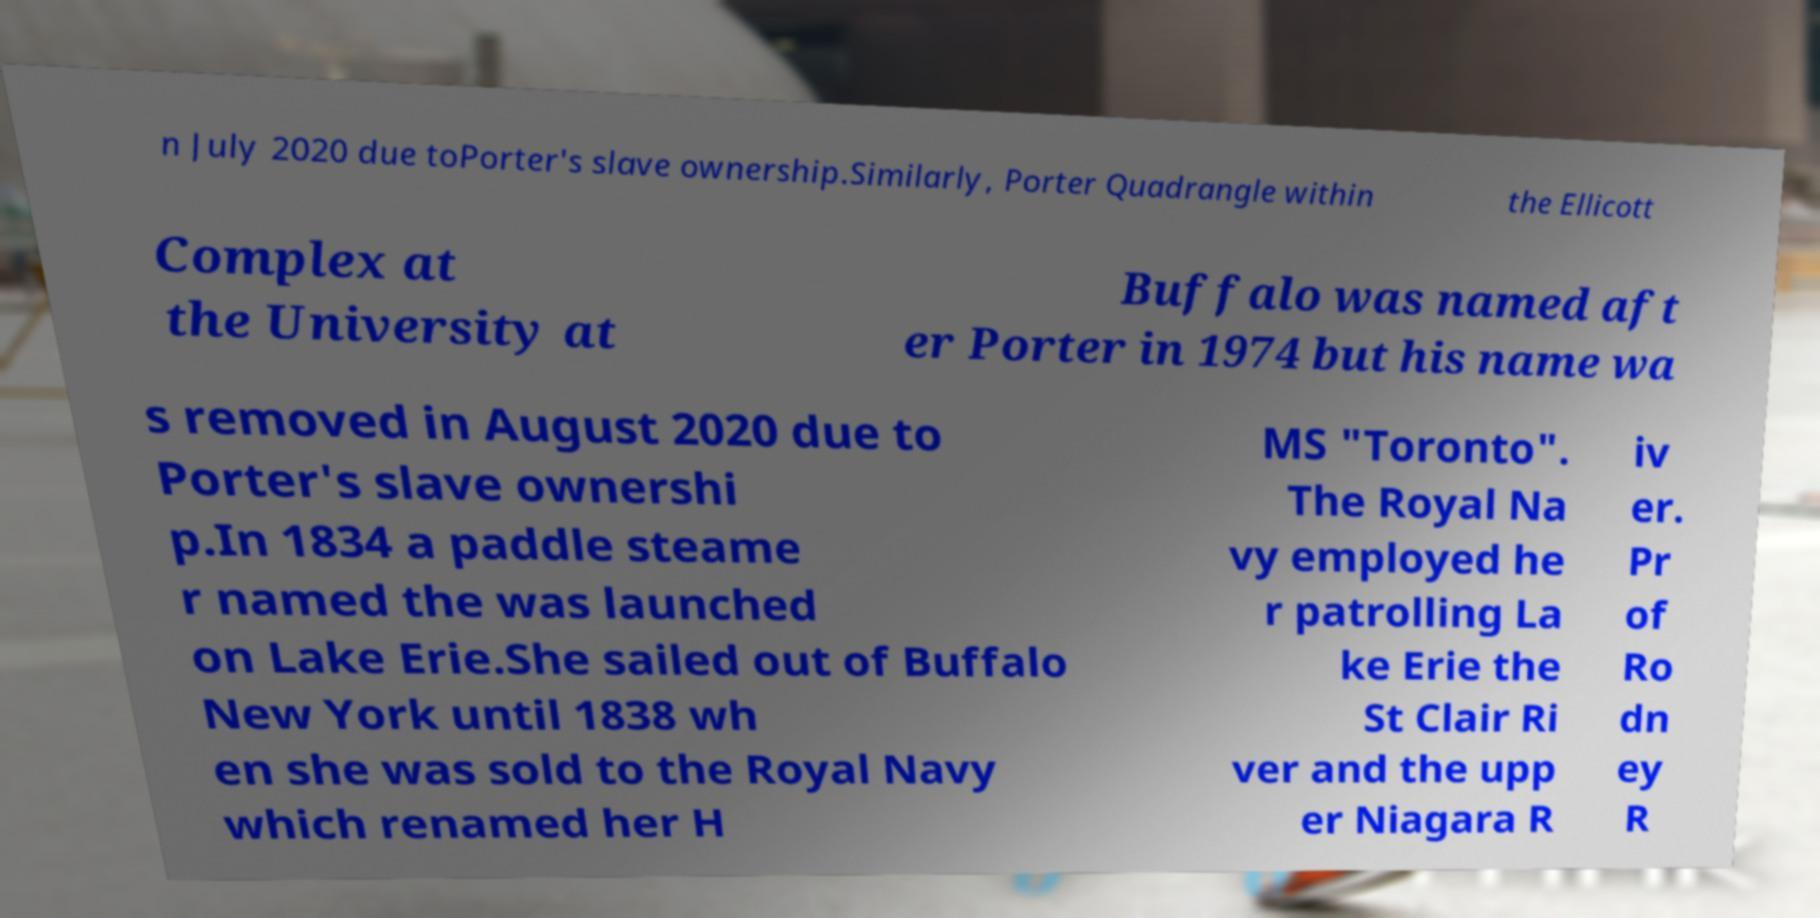Could you assist in decoding the text presented in this image and type it out clearly? n July 2020 due toPorter's slave ownership.Similarly, Porter Quadrangle within the Ellicott Complex at the University at Buffalo was named aft er Porter in 1974 but his name wa s removed in August 2020 due to Porter's slave ownershi p.In 1834 a paddle steame r named the was launched on Lake Erie.She sailed out of Buffalo New York until 1838 wh en she was sold to the Royal Navy which renamed her H MS "Toronto". The Royal Na vy employed he r patrolling La ke Erie the St Clair Ri ver and the upp er Niagara R iv er. Pr of Ro dn ey R 